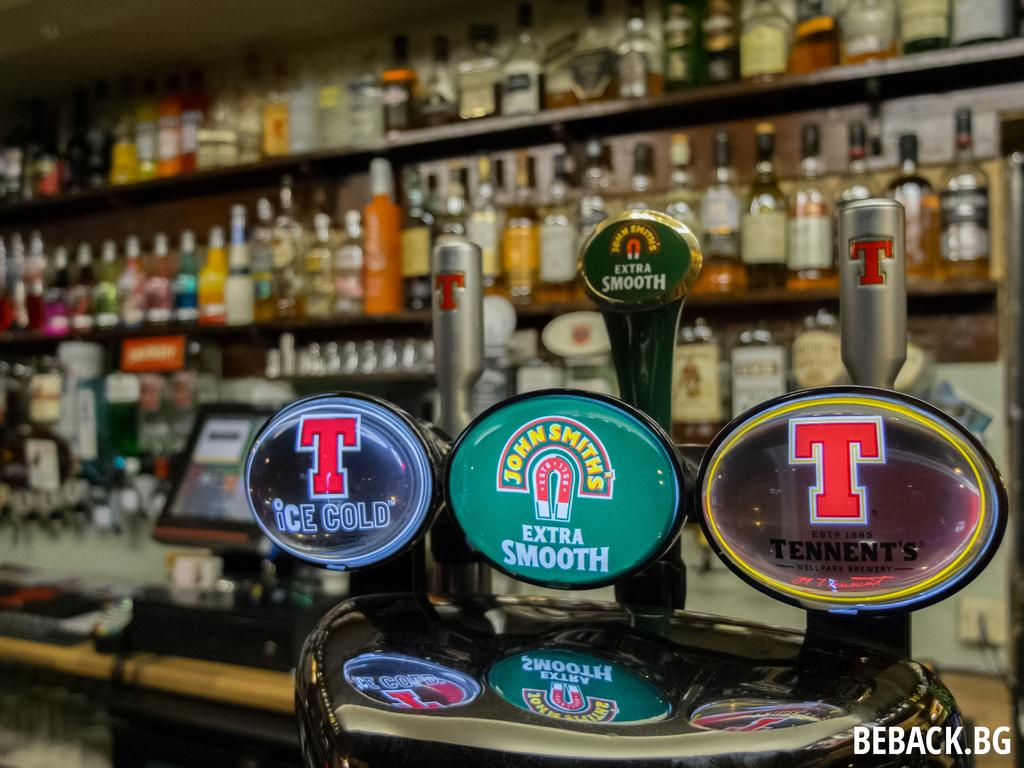<image>
Create a compact narrative representing the image presented. A line of beer taps, including Tennent's Ice Cold and John Smith's Extra Smooth. 